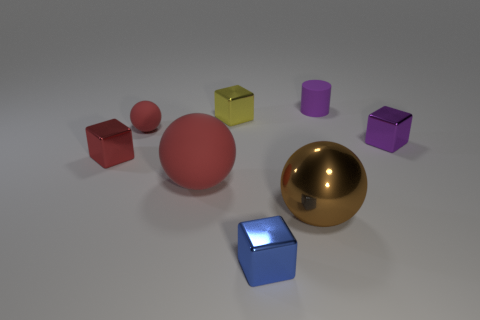What number of other things are there of the same size as the blue metallic object?
Your answer should be very brief. 5. The brown sphere is what size?
Keep it short and to the point. Large. There is a purple thing that is in front of the purple rubber thing; what size is it?
Keep it short and to the point. Small. There is a cube that is right of the blue thing; is its size the same as the tiny red ball?
Your answer should be compact. Yes. Are there any other things that have the same color as the metal sphere?
Ensure brevity in your answer.  No. What shape is the brown shiny object?
Give a very brief answer. Sphere. What number of things are in front of the small sphere and on the right side of the large brown thing?
Offer a very short reply. 1. Does the large rubber object have the same color as the cylinder?
Your response must be concise. No. There is a purple thing that is the same shape as the tiny blue object; what material is it?
Make the answer very short. Metal. Is there anything else that is the same material as the small red cube?
Give a very brief answer. Yes. 